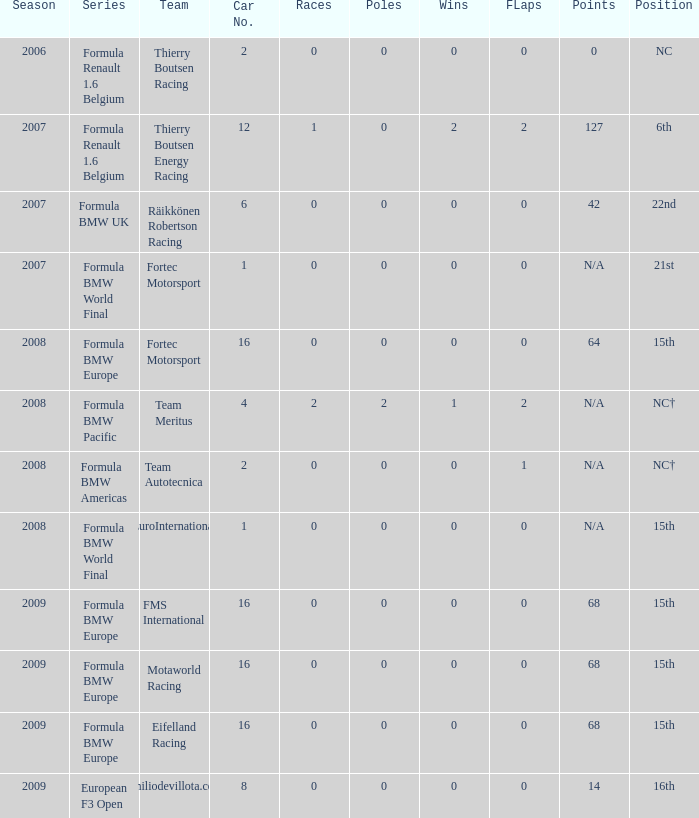Identify the role within eifelland racing. 15th. 